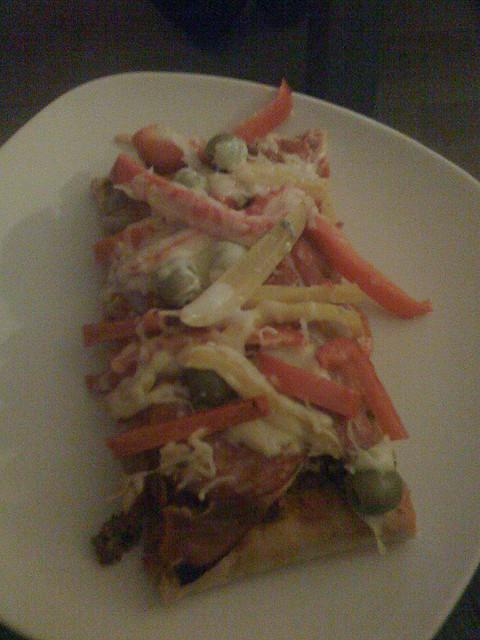The toppings are primarily from what food group? vegetables 